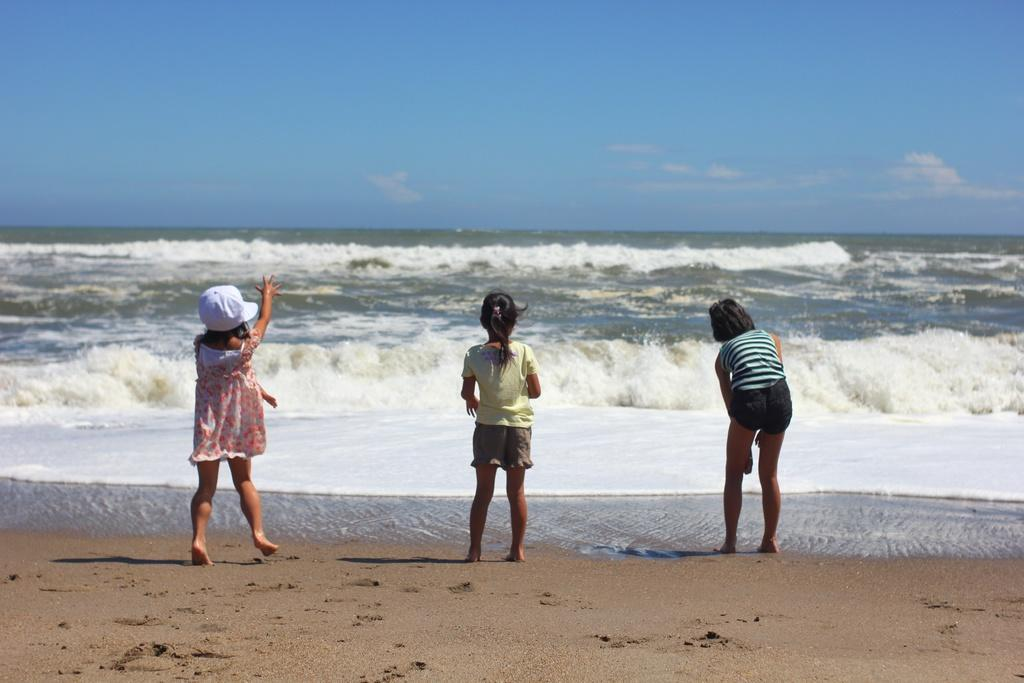What are the main subjects in the image? There are kids standing in the center of the image. What can be seen in the background of the image? There is an ocean in the background of the image. How would you describe the sky in the image? The sky is cloudy. What type of terrain is visible in the front of the image? There is sand on the ground in the front of the image. What type of produce is being harvested in the image? There is no produce visible in the image; it features kids standing near an ocean with a cloudy sky and sandy terrain. Is there a record player present in the image? There is no record player or any audio equipment visible in the image. 